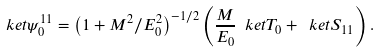Convert formula to latex. <formula><loc_0><loc_0><loc_500><loc_500>\ k e t { \psi _ { 0 } ^ { 1 1 } } = \left ( 1 + M ^ { 2 } / E _ { 0 } ^ { 2 } \right ) ^ { - 1 / 2 } \left ( \frac { M } { E _ { 0 } } \ k e t { T _ { 0 } } + \ k e t { S _ { 1 1 } } \right ) .</formula> 